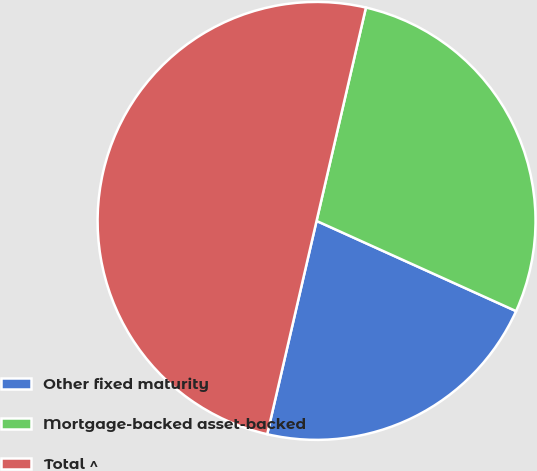Convert chart to OTSL. <chart><loc_0><loc_0><loc_500><loc_500><pie_chart><fcel>Other fixed maturity<fcel>Mortgage-backed asset-backed<fcel>Total ^<nl><fcel>21.86%<fcel>28.14%<fcel>50.0%<nl></chart> 